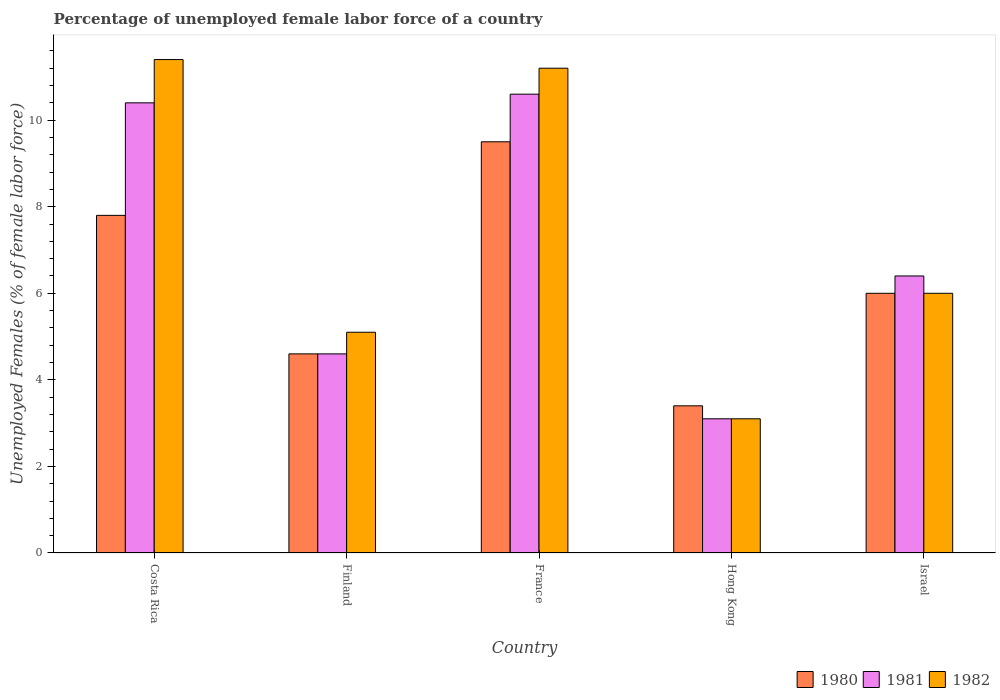Are the number of bars per tick equal to the number of legend labels?
Offer a very short reply. Yes. How many bars are there on the 5th tick from the right?
Provide a succinct answer. 3. In how many cases, is the number of bars for a given country not equal to the number of legend labels?
Make the answer very short. 0. What is the percentage of unemployed female labor force in 1980 in Finland?
Ensure brevity in your answer.  4.6. Across all countries, what is the maximum percentage of unemployed female labor force in 1981?
Your response must be concise. 10.6. Across all countries, what is the minimum percentage of unemployed female labor force in 1982?
Your answer should be very brief. 3.1. In which country was the percentage of unemployed female labor force in 1982 minimum?
Offer a terse response. Hong Kong. What is the total percentage of unemployed female labor force in 1981 in the graph?
Offer a very short reply. 35.1. What is the difference between the percentage of unemployed female labor force in 1980 in Costa Rica and that in Israel?
Offer a terse response. 1.8. What is the difference between the percentage of unemployed female labor force in 1980 in France and the percentage of unemployed female labor force in 1981 in Israel?
Provide a short and direct response. 3.1. What is the average percentage of unemployed female labor force in 1982 per country?
Provide a succinct answer. 7.36. What is the difference between the percentage of unemployed female labor force of/in 1980 and percentage of unemployed female labor force of/in 1982 in Finland?
Provide a succinct answer. -0.5. What is the ratio of the percentage of unemployed female labor force in 1982 in France to that in Israel?
Give a very brief answer. 1.87. What is the difference between the highest and the second highest percentage of unemployed female labor force in 1982?
Offer a terse response. -0.2. What is the difference between the highest and the lowest percentage of unemployed female labor force in 1982?
Your answer should be compact. 8.3. Is the sum of the percentage of unemployed female labor force in 1981 in France and Hong Kong greater than the maximum percentage of unemployed female labor force in 1982 across all countries?
Offer a terse response. Yes. What does the 2nd bar from the left in Finland represents?
Provide a succinct answer. 1981. Is it the case that in every country, the sum of the percentage of unemployed female labor force in 1981 and percentage of unemployed female labor force in 1982 is greater than the percentage of unemployed female labor force in 1980?
Ensure brevity in your answer.  Yes. What is the difference between two consecutive major ticks on the Y-axis?
Make the answer very short. 2. Does the graph contain any zero values?
Your answer should be very brief. No. Does the graph contain grids?
Provide a succinct answer. No. Where does the legend appear in the graph?
Ensure brevity in your answer.  Bottom right. How are the legend labels stacked?
Offer a very short reply. Horizontal. What is the title of the graph?
Offer a terse response. Percentage of unemployed female labor force of a country. What is the label or title of the X-axis?
Your answer should be very brief. Country. What is the label or title of the Y-axis?
Offer a very short reply. Unemployed Females (% of female labor force). What is the Unemployed Females (% of female labor force) in 1980 in Costa Rica?
Your response must be concise. 7.8. What is the Unemployed Females (% of female labor force) in 1981 in Costa Rica?
Your answer should be compact. 10.4. What is the Unemployed Females (% of female labor force) in 1982 in Costa Rica?
Give a very brief answer. 11.4. What is the Unemployed Females (% of female labor force) of 1980 in Finland?
Provide a succinct answer. 4.6. What is the Unemployed Females (% of female labor force) of 1981 in Finland?
Give a very brief answer. 4.6. What is the Unemployed Females (% of female labor force) of 1982 in Finland?
Ensure brevity in your answer.  5.1. What is the Unemployed Females (% of female labor force) of 1980 in France?
Make the answer very short. 9.5. What is the Unemployed Females (% of female labor force) in 1981 in France?
Provide a short and direct response. 10.6. What is the Unemployed Females (% of female labor force) in 1982 in France?
Offer a very short reply. 11.2. What is the Unemployed Females (% of female labor force) of 1980 in Hong Kong?
Your response must be concise. 3.4. What is the Unemployed Females (% of female labor force) of 1981 in Hong Kong?
Provide a short and direct response. 3.1. What is the Unemployed Females (% of female labor force) of 1982 in Hong Kong?
Your answer should be compact. 3.1. What is the Unemployed Females (% of female labor force) of 1980 in Israel?
Your answer should be compact. 6. What is the Unemployed Females (% of female labor force) of 1981 in Israel?
Your answer should be very brief. 6.4. Across all countries, what is the maximum Unemployed Females (% of female labor force) of 1981?
Offer a terse response. 10.6. Across all countries, what is the maximum Unemployed Females (% of female labor force) in 1982?
Provide a short and direct response. 11.4. Across all countries, what is the minimum Unemployed Females (% of female labor force) in 1980?
Keep it short and to the point. 3.4. Across all countries, what is the minimum Unemployed Females (% of female labor force) of 1981?
Make the answer very short. 3.1. Across all countries, what is the minimum Unemployed Females (% of female labor force) of 1982?
Ensure brevity in your answer.  3.1. What is the total Unemployed Females (% of female labor force) in 1980 in the graph?
Your answer should be very brief. 31.3. What is the total Unemployed Females (% of female labor force) in 1981 in the graph?
Your answer should be compact. 35.1. What is the total Unemployed Females (% of female labor force) of 1982 in the graph?
Keep it short and to the point. 36.8. What is the difference between the Unemployed Females (% of female labor force) of 1982 in Costa Rica and that in Finland?
Keep it short and to the point. 6.3. What is the difference between the Unemployed Females (% of female labor force) of 1980 in Costa Rica and that in France?
Offer a terse response. -1.7. What is the difference between the Unemployed Females (% of female labor force) of 1982 in Costa Rica and that in France?
Ensure brevity in your answer.  0.2. What is the difference between the Unemployed Females (% of female labor force) in 1980 in Costa Rica and that in Israel?
Offer a very short reply. 1.8. What is the difference between the Unemployed Females (% of female labor force) of 1980 in Finland and that in France?
Provide a succinct answer. -4.9. What is the difference between the Unemployed Females (% of female labor force) in 1981 in Finland and that in France?
Provide a short and direct response. -6. What is the difference between the Unemployed Females (% of female labor force) in 1982 in Finland and that in France?
Give a very brief answer. -6.1. What is the difference between the Unemployed Females (% of female labor force) of 1982 in Finland and that in Hong Kong?
Your answer should be compact. 2. What is the difference between the Unemployed Females (% of female labor force) in 1982 in France and that in Hong Kong?
Ensure brevity in your answer.  8.1. What is the difference between the Unemployed Females (% of female labor force) in 1980 in Hong Kong and that in Israel?
Provide a short and direct response. -2.6. What is the difference between the Unemployed Females (% of female labor force) in 1981 in Hong Kong and that in Israel?
Ensure brevity in your answer.  -3.3. What is the difference between the Unemployed Females (% of female labor force) in 1980 in Costa Rica and the Unemployed Females (% of female labor force) in 1981 in Finland?
Offer a very short reply. 3.2. What is the difference between the Unemployed Females (% of female labor force) of 1980 in Costa Rica and the Unemployed Females (% of female labor force) of 1982 in Finland?
Keep it short and to the point. 2.7. What is the difference between the Unemployed Females (% of female labor force) in 1980 in Costa Rica and the Unemployed Females (% of female labor force) in 1982 in France?
Ensure brevity in your answer.  -3.4. What is the difference between the Unemployed Females (% of female labor force) in 1981 in Costa Rica and the Unemployed Females (% of female labor force) in 1982 in France?
Keep it short and to the point. -0.8. What is the difference between the Unemployed Females (% of female labor force) in 1980 in Costa Rica and the Unemployed Females (% of female labor force) in 1981 in Hong Kong?
Make the answer very short. 4.7. What is the difference between the Unemployed Females (% of female labor force) of 1980 in Costa Rica and the Unemployed Females (% of female labor force) of 1982 in Hong Kong?
Give a very brief answer. 4.7. What is the difference between the Unemployed Females (% of female labor force) in 1981 in Costa Rica and the Unemployed Females (% of female labor force) in 1982 in Israel?
Your answer should be compact. 4.4. What is the difference between the Unemployed Females (% of female labor force) in 1980 in Finland and the Unemployed Females (% of female labor force) in 1981 in Hong Kong?
Give a very brief answer. 1.5. What is the difference between the Unemployed Females (% of female labor force) in 1981 in Finland and the Unemployed Females (% of female labor force) in 1982 in Hong Kong?
Provide a succinct answer. 1.5. What is the difference between the Unemployed Females (% of female labor force) in 1980 in France and the Unemployed Females (% of female labor force) in 1982 in Hong Kong?
Give a very brief answer. 6.4. What is the difference between the Unemployed Females (% of female labor force) of 1981 in France and the Unemployed Females (% of female labor force) of 1982 in Hong Kong?
Your response must be concise. 7.5. What is the difference between the Unemployed Females (% of female labor force) in 1980 in France and the Unemployed Females (% of female labor force) in 1981 in Israel?
Offer a very short reply. 3.1. What is the difference between the Unemployed Females (% of female labor force) in 1980 in France and the Unemployed Females (% of female labor force) in 1982 in Israel?
Your answer should be compact. 3.5. What is the difference between the Unemployed Females (% of female labor force) in 1981 in France and the Unemployed Females (% of female labor force) in 1982 in Israel?
Give a very brief answer. 4.6. What is the average Unemployed Females (% of female labor force) in 1980 per country?
Give a very brief answer. 6.26. What is the average Unemployed Females (% of female labor force) of 1981 per country?
Provide a short and direct response. 7.02. What is the average Unemployed Females (% of female labor force) in 1982 per country?
Your answer should be very brief. 7.36. What is the difference between the Unemployed Females (% of female labor force) of 1980 and Unemployed Females (% of female labor force) of 1982 in Costa Rica?
Offer a very short reply. -3.6. What is the difference between the Unemployed Females (% of female labor force) in 1981 and Unemployed Females (% of female labor force) in 1982 in Costa Rica?
Offer a very short reply. -1. What is the difference between the Unemployed Females (% of female labor force) of 1981 and Unemployed Females (% of female labor force) of 1982 in France?
Offer a very short reply. -0.6. What is the difference between the Unemployed Females (% of female labor force) in 1980 and Unemployed Females (% of female labor force) in 1982 in Hong Kong?
Provide a succinct answer. 0.3. What is the difference between the Unemployed Females (% of female labor force) in 1980 and Unemployed Females (% of female labor force) in 1981 in Israel?
Offer a very short reply. -0.4. What is the difference between the Unemployed Females (% of female labor force) in 1980 and Unemployed Females (% of female labor force) in 1982 in Israel?
Provide a short and direct response. 0. What is the difference between the Unemployed Females (% of female labor force) of 1981 and Unemployed Females (% of female labor force) of 1982 in Israel?
Your answer should be very brief. 0.4. What is the ratio of the Unemployed Females (% of female labor force) in 1980 in Costa Rica to that in Finland?
Your response must be concise. 1.7. What is the ratio of the Unemployed Females (% of female labor force) in 1981 in Costa Rica to that in Finland?
Keep it short and to the point. 2.26. What is the ratio of the Unemployed Females (% of female labor force) of 1982 in Costa Rica to that in Finland?
Provide a short and direct response. 2.24. What is the ratio of the Unemployed Females (% of female labor force) of 1980 in Costa Rica to that in France?
Make the answer very short. 0.82. What is the ratio of the Unemployed Females (% of female labor force) in 1981 in Costa Rica to that in France?
Your answer should be compact. 0.98. What is the ratio of the Unemployed Females (% of female labor force) in 1982 in Costa Rica to that in France?
Your response must be concise. 1.02. What is the ratio of the Unemployed Females (% of female labor force) of 1980 in Costa Rica to that in Hong Kong?
Make the answer very short. 2.29. What is the ratio of the Unemployed Females (% of female labor force) in 1981 in Costa Rica to that in Hong Kong?
Offer a very short reply. 3.35. What is the ratio of the Unemployed Females (% of female labor force) of 1982 in Costa Rica to that in Hong Kong?
Give a very brief answer. 3.68. What is the ratio of the Unemployed Females (% of female labor force) of 1980 in Costa Rica to that in Israel?
Offer a very short reply. 1.3. What is the ratio of the Unemployed Females (% of female labor force) of 1981 in Costa Rica to that in Israel?
Give a very brief answer. 1.62. What is the ratio of the Unemployed Females (% of female labor force) of 1982 in Costa Rica to that in Israel?
Your answer should be very brief. 1.9. What is the ratio of the Unemployed Females (% of female labor force) in 1980 in Finland to that in France?
Your answer should be very brief. 0.48. What is the ratio of the Unemployed Females (% of female labor force) of 1981 in Finland to that in France?
Ensure brevity in your answer.  0.43. What is the ratio of the Unemployed Females (% of female labor force) of 1982 in Finland to that in France?
Ensure brevity in your answer.  0.46. What is the ratio of the Unemployed Females (% of female labor force) of 1980 in Finland to that in Hong Kong?
Provide a succinct answer. 1.35. What is the ratio of the Unemployed Females (% of female labor force) in 1981 in Finland to that in Hong Kong?
Your answer should be very brief. 1.48. What is the ratio of the Unemployed Females (% of female labor force) in 1982 in Finland to that in Hong Kong?
Your response must be concise. 1.65. What is the ratio of the Unemployed Females (% of female labor force) in 1980 in Finland to that in Israel?
Make the answer very short. 0.77. What is the ratio of the Unemployed Females (% of female labor force) of 1981 in Finland to that in Israel?
Keep it short and to the point. 0.72. What is the ratio of the Unemployed Females (% of female labor force) in 1982 in Finland to that in Israel?
Your answer should be compact. 0.85. What is the ratio of the Unemployed Females (% of female labor force) in 1980 in France to that in Hong Kong?
Provide a short and direct response. 2.79. What is the ratio of the Unemployed Females (% of female labor force) in 1981 in France to that in Hong Kong?
Your answer should be compact. 3.42. What is the ratio of the Unemployed Females (% of female labor force) in 1982 in France to that in Hong Kong?
Offer a very short reply. 3.61. What is the ratio of the Unemployed Females (% of female labor force) in 1980 in France to that in Israel?
Your answer should be compact. 1.58. What is the ratio of the Unemployed Females (% of female labor force) in 1981 in France to that in Israel?
Your answer should be very brief. 1.66. What is the ratio of the Unemployed Females (% of female labor force) of 1982 in France to that in Israel?
Offer a terse response. 1.87. What is the ratio of the Unemployed Females (% of female labor force) of 1980 in Hong Kong to that in Israel?
Your response must be concise. 0.57. What is the ratio of the Unemployed Females (% of female labor force) of 1981 in Hong Kong to that in Israel?
Provide a short and direct response. 0.48. What is the ratio of the Unemployed Females (% of female labor force) of 1982 in Hong Kong to that in Israel?
Offer a very short reply. 0.52. What is the difference between the highest and the lowest Unemployed Females (% of female labor force) of 1981?
Make the answer very short. 7.5. What is the difference between the highest and the lowest Unemployed Females (% of female labor force) in 1982?
Keep it short and to the point. 8.3. 